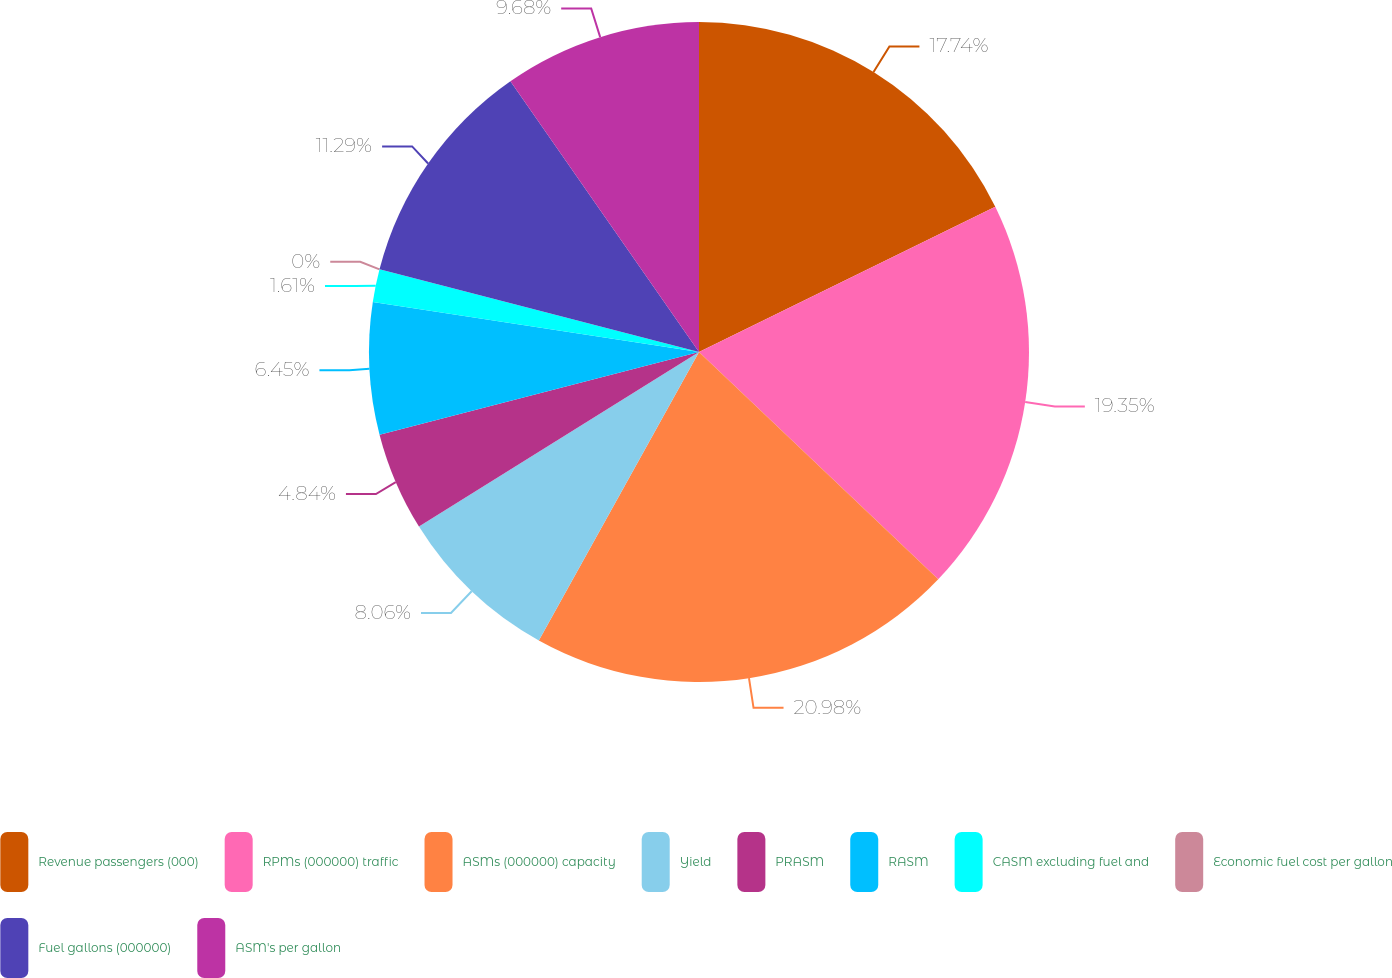Convert chart to OTSL. <chart><loc_0><loc_0><loc_500><loc_500><pie_chart><fcel>Revenue passengers (000)<fcel>RPMs (000000) traffic<fcel>ASMs (000000) capacity<fcel>Yield<fcel>PRASM<fcel>RASM<fcel>CASM excluding fuel and<fcel>Economic fuel cost per gallon<fcel>Fuel gallons (000000)<fcel>ASM's per gallon<nl><fcel>17.74%<fcel>19.35%<fcel>20.97%<fcel>8.06%<fcel>4.84%<fcel>6.45%<fcel>1.61%<fcel>0.0%<fcel>11.29%<fcel>9.68%<nl></chart> 